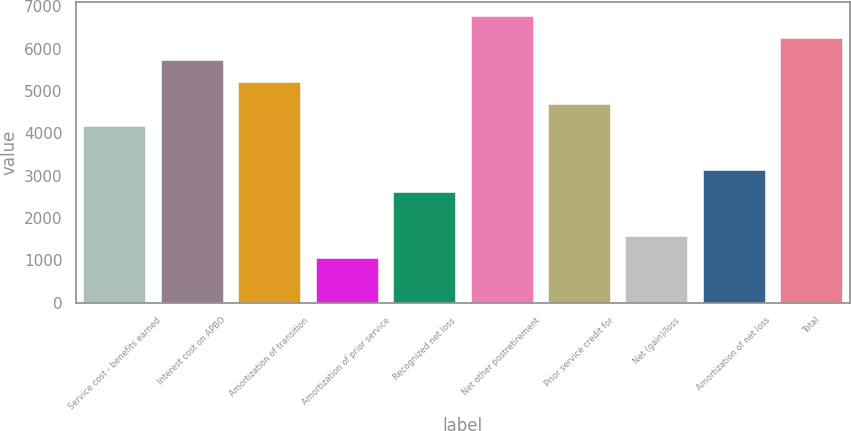<chart> <loc_0><loc_0><loc_500><loc_500><bar_chart><fcel>Service cost - benefits earned<fcel>Interest cost on APBO<fcel>Amortization of transition<fcel>Amortization of prior service<fcel>Recognized net loss<fcel>Net other postretirement<fcel>Prior service credit for<fcel>Net (gain)/loss<fcel>Amortization of net loss<fcel>Total<nl><fcel>4168.6<fcel>5723.2<fcel>5205<fcel>1059.4<fcel>2614<fcel>6759.6<fcel>4686.8<fcel>1577.6<fcel>3132.2<fcel>6241.4<nl></chart> 